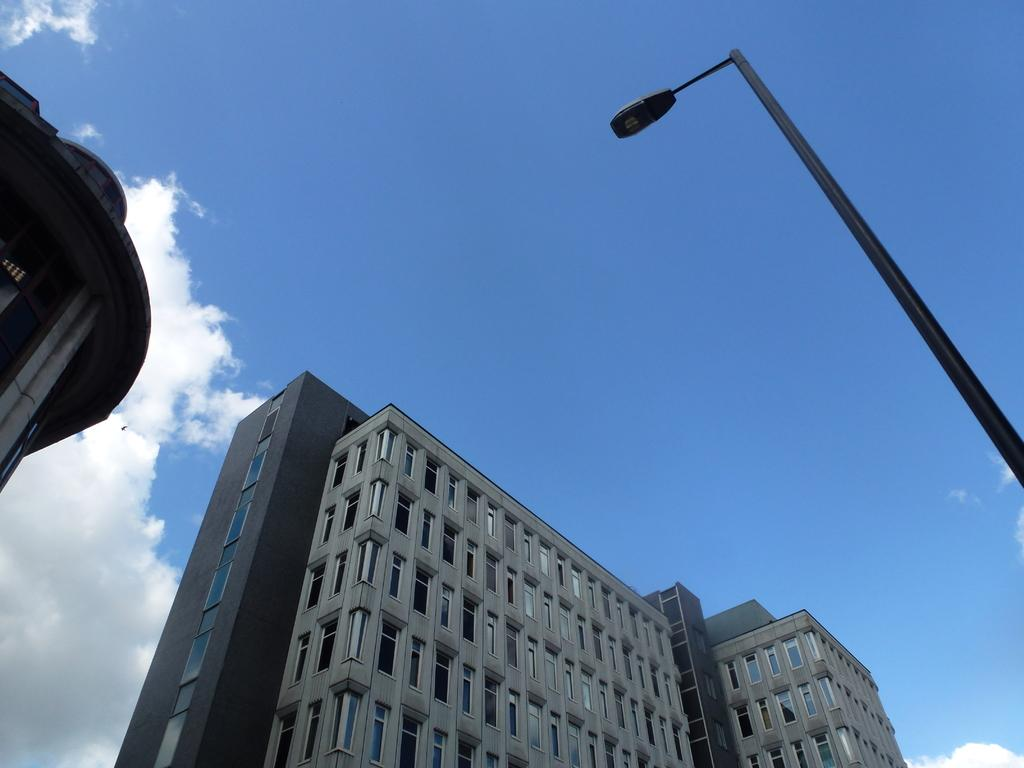What type of structures can be seen in the image? There are buildings in the image. What other object can be seen in the image besides the buildings? There is a pole in the image. What is the condition of the sky in the image? The sky is cloudy in the image. How many bushes are growing around the pole in the image? There are no bushes visible around the pole in the image. What type of bottle is sitting on top of the building in the image? There is no bottle present on top of any building in the image. 